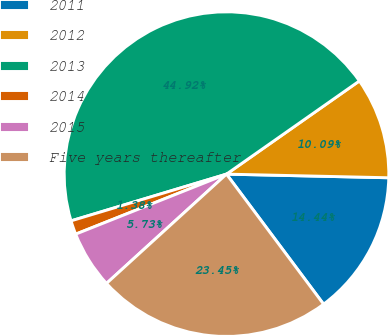<chart> <loc_0><loc_0><loc_500><loc_500><pie_chart><fcel>2011<fcel>2012<fcel>2013<fcel>2014<fcel>2015<fcel>Five years thereafter<nl><fcel>14.44%<fcel>10.09%<fcel>44.92%<fcel>1.38%<fcel>5.73%<fcel>23.45%<nl></chart> 